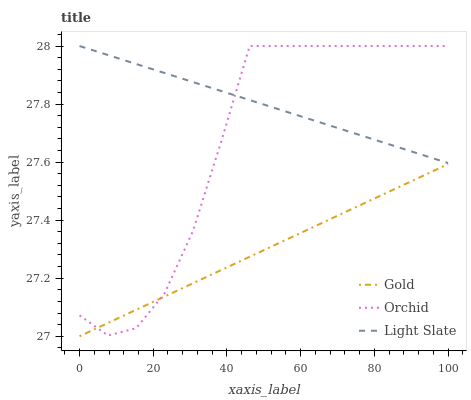Does Orchid have the minimum area under the curve?
Answer yes or no. No. Does Orchid have the maximum area under the curve?
Answer yes or no. No. Is Gold the smoothest?
Answer yes or no. No. Is Gold the roughest?
Answer yes or no. No. Does Orchid have the lowest value?
Answer yes or no. No. Does Gold have the highest value?
Answer yes or no. No. Is Gold less than Light Slate?
Answer yes or no. Yes. Is Light Slate greater than Gold?
Answer yes or no. Yes. Does Gold intersect Light Slate?
Answer yes or no. No. 